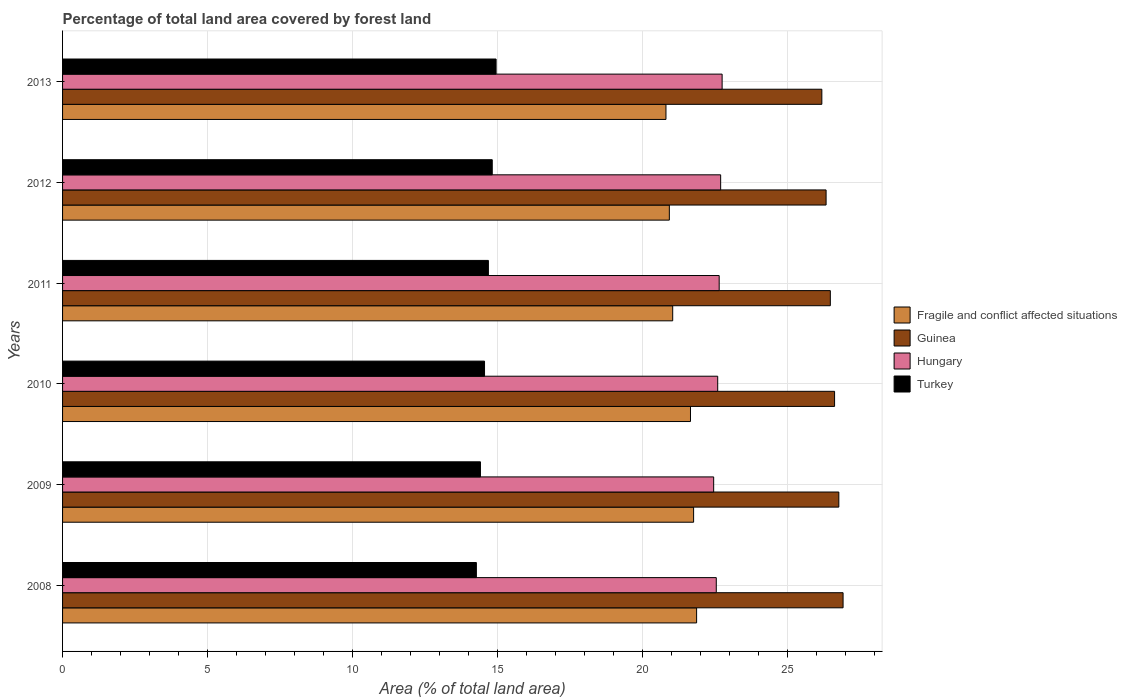How many groups of bars are there?
Your answer should be very brief. 6. What is the label of the 6th group of bars from the top?
Keep it short and to the point. 2008. What is the percentage of forest land in Fragile and conflict affected situations in 2010?
Ensure brevity in your answer.  21.66. Across all years, what is the maximum percentage of forest land in Guinea?
Ensure brevity in your answer.  26.92. Across all years, what is the minimum percentage of forest land in Guinea?
Give a very brief answer. 26.19. In which year was the percentage of forest land in Hungary minimum?
Your answer should be compact. 2009. What is the total percentage of forest land in Hungary in the graph?
Ensure brevity in your answer.  135.72. What is the difference between the percentage of forest land in Fragile and conflict affected situations in 2010 and that in 2012?
Provide a short and direct response. 0.73. What is the difference between the percentage of forest land in Guinea in 2009 and the percentage of forest land in Fragile and conflict affected situations in 2013?
Ensure brevity in your answer.  5.96. What is the average percentage of forest land in Guinea per year?
Your answer should be compact. 26.56. In the year 2012, what is the difference between the percentage of forest land in Fragile and conflict affected situations and percentage of forest land in Hungary?
Offer a very short reply. -1.77. In how many years, is the percentage of forest land in Hungary greater than 20 %?
Provide a short and direct response. 6. What is the ratio of the percentage of forest land in Hungary in 2008 to that in 2012?
Your answer should be compact. 0.99. What is the difference between the highest and the second highest percentage of forest land in Guinea?
Give a very brief answer. 0.15. What is the difference between the highest and the lowest percentage of forest land in Fragile and conflict affected situations?
Your answer should be compact. 1.06. What does the 2nd bar from the top in 2013 represents?
Give a very brief answer. Hungary. Are all the bars in the graph horizontal?
Offer a terse response. Yes. What is the difference between two consecutive major ticks on the X-axis?
Provide a succinct answer. 5. Are the values on the major ticks of X-axis written in scientific E-notation?
Offer a very short reply. No. Does the graph contain grids?
Provide a succinct answer. Yes. How are the legend labels stacked?
Your answer should be very brief. Vertical. What is the title of the graph?
Ensure brevity in your answer.  Percentage of total land area covered by forest land. What is the label or title of the X-axis?
Your answer should be very brief. Area (% of total land area). What is the Area (% of total land area) in Fragile and conflict affected situations in 2008?
Give a very brief answer. 21.87. What is the Area (% of total land area) in Guinea in 2008?
Your answer should be compact. 26.92. What is the Area (% of total land area) of Hungary in 2008?
Offer a terse response. 22.55. What is the Area (% of total land area) in Turkey in 2008?
Offer a terse response. 14.28. What is the Area (% of total land area) in Fragile and conflict affected situations in 2009?
Make the answer very short. 21.77. What is the Area (% of total land area) in Guinea in 2009?
Provide a short and direct response. 26.78. What is the Area (% of total land area) of Hungary in 2009?
Make the answer very short. 22.46. What is the Area (% of total land area) of Turkey in 2009?
Offer a terse response. 14.42. What is the Area (% of total land area) in Fragile and conflict affected situations in 2010?
Your answer should be very brief. 21.66. What is the Area (% of total land area) in Guinea in 2010?
Your response must be concise. 26.63. What is the Area (% of total land area) in Hungary in 2010?
Provide a succinct answer. 22.6. What is the Area (% of total land area) of Turkey in 2010?
Keep it short and to the point. 14.56. What is the Area (% of total land area) of Fragile and conflict affected situations in 2011?
Give a very brief answer. 21.05. What is the Area (% of total land area) of Guinea in 2011?
Make the answer very short. 26.49. What is the Area (% of total land area) in Hungary in 2011?
Offer a very short reply. 22.65. What is the Area (% of total land area) of Turkey in 2011?
Your answer should be very brief. 14.69. What is the Area (% of total land area) of Fragile and conflict affected situations in 2012?
Your answer should be very brief. 20.93. What is the Area (% of total land area) in Guinea in 2012?
Your answer should be very brief. 26.34. What is the Area (% of total land area) of Hungary in 2012?
Offer a terse response. 22.7. What is the Area (% of total land area) of Turkey in 2012?
Keep it short and to the point. 14.82. What is the Area (% of total land area) of Fragile and conflict affected situations in 2013?
Your answer should be compact. 20.82. What is the Area (% of total land area) in Guinea in 2013?
Your answer should be very brief. 26.19. What is the Area (% of total land area) of Hungary in 2013?
Ensure brevity in your answer.  22.75. What is the Area (% of total land area) of Turkey in 2013?
Provide a succinct answer. 14.96. Across all years, what is the maximum Area (% of total land area) of Fragile and conflict affected situations?
Ensure brevity in your answer.  21.87. Across all years, what is the maximum Area (% of total land area) of Guinea?
Make the answer very short. 26.92. Across all years, what is the maximum Area (% of total land area) of Hungary?
Provide a succinct answer. 22.75. Across all years, what is the maximum Area (% of total land area) of Turkey?
Your answer should be very brief. 14.96. Across all years, what is the minimum Area (% of total land area) of Fragile and conflict affected situations?
Ensure brevity in your answer.  20.82. Across all years, what is the minimum Area (% of total land area) in Guinea?
Your answer should be very brief. 26.19. Across all years, what is the minimum Area (% of total land area) of Hungary?
Your answer should be very brief. 22.46. Across all years, what is the minimum Area (% of total land area) of Turkey?
Your answer should be compact. 14.28. What is the total Area (% of total land area) of Fragile and conflict affected situations in the graph?
Offer a very short reply. 128.1. What is the total Area (% of total land area) of Guinea in the graph?
Your answer should be very brief. 159.35. What is the total Area (% of total land area) of Hungary in the graph?
Make the answer very short. 135.72. What is the total Area (% of total land area) in Turkey in the graph?
Keep it short and to the point. 87.71. What is the difference between the Area (% of total land area) of Fragile and conflict affected situations in 2008 and that in 2009?
Offer a terse response. 0.1. What is the difference between the Area (% of total land area) of Guinea in 2008 and that in 2009?
Provide a short and direct response. 0.15. What is the difference between the Area (% of total land area) in Hungary in 2008 and that in 2009?
Give a very brief answer. 0.09. What is the difference between the Area (% of total land area) of Turkey in 2008 and that in 2009?
Keep it short and to the point. -0.14. What is the difference between the Area (% of total land area) of Fragile and conflict affected situations in 2008 and that in 2010?
Your answer should be compact. 0.21. What is the difference between the Area (% of total land area) of Guinea in 2008 and that in 2010?
Offer a very short reply. 0.29. What is the difference between the Area (% of total land area) of Hungary in 2008 and that in 2010?
Keep it short and to the point. -0.05. What is the difference between the Area (% of total land area) in Turkey in 2008 and that in 2010?
Offer a terse response. -0.28. What is the difference between the Area (% of total land area) of Fragile and conflict affected situations in 2008 and that in 2011?
Offer a very short reply. 0.83. What is the difference between the Area (% of total land area) in Guinea in 2008 and that in 2011?
Provide a short and direct response. 0.44. What is the difference between the Area (% of total land area) of Hungary in 2008 and that in 2011?
Offer a very short reply. -0.1. What is the difference between the Area (% of total land area) of Turkey in 2008 and that in 2011?
Your answer should be very brief. -0.41. What is the difference between the Area (% of total land area) of Fragile and conflict affected situations in 2008 and that in 2012?
Provide a succinct answer. 0.94. What is the difference between the Area (% of total land area) of Guinea in 2008 and that in 2012?
Provide a short and direct response. 0.59. What is the difference between the Area (% of total land area) in Hungary in 2008 and that in 2012?
Provide a short and direct response. -0.15. What is the difference between the Area (% of total land area) of Turkey in 2008 and that in 2012?
Offer a very short reply. -0.55. What is the difference between the Area (% of total land area) in Fragile and conflict affected situations in 2008 and that in 2013?
Give a very brief answer. 1.06. What is the difference between the Area (% of total land area) in Guinea in 2008 and that in 2013?
Offer a terse response. 0.73. What is the difference between the Area (% of total land area) in Hungary in 2008 and that in 2013?
Offer a very short reply. -0.2. What is the difference between the Area (% of total land area) of Turkey in 2008 and that in 2013?
Keep it short and to the point. -0.68. What is the difference between the Area (% of total land area) in Fragile and conflict affected situations in 2009 and that in 2010?
Your answer should be very brief. 0.11. What is the difference between the Area (% of total land area) of Guinea in 2009 and that in 2010?
Offer a terse response. 0.15. What is the difference between the Area (% of total land area) of Hungary in 2009 and that in 2010?
Your answer should be very brief. -0.14. What is the difference between the Area (% of total land area) of Turkey in 2009 and that in 2010?
Your answer should be very brief. -0.14. What is the difference between the Area (% of total land area) in Fragile and conflict affected situations in 2009 and that in 2011?
Make the answer very short. 0.72. What is the difference between the Area (% of total land area) in Guinea in 2009 and that in 2011?
Provide a short and direct response. 0.29. What is the difference between the Area (% of total land area) in Hungary in 2009 and that in 2011?
Provide a short and direct response. -0.19. What is the difference between the Area (% of total land area) in Turkey in 2009 and that in 2011?
Provide a short and direct response. -0.27. What is the difference between the Area (% of total land area) of Fragile and conflict affected situations in 2009 and that in 2012?
Offer a terse response. 0.84. What is the difference between the Area (% of total land area) in Guinea in 2009 and that in 2012?
Provide a succinct answer. 0.44. What is the difference between the Area (% of total land area) in Hungary in 2009 and that in 2012?
Ensure brevity in your answer.  -0.24. What is the difference between the Area (% of total land area) in Turkey in 2009 and that in 2012?
Make the answer very short. -0.41. What is the difference between the Area (% of total land area) of Fragile and conflict affected situations in 2009 and that in 2013?
Keep it short and to the point. 0.95. What is the difference between the Area (% of total land area) in Guinea in 2009 and that in 2013?
Your response must be concise. 0.59. What is the difference between the Area (% of total land area) in Hungary in 2009 and that in 2013?
Provide a succinct answer. -0.29. What is the difference between the Area (% of total land area) in Turkey in 2009 and that in 2013?
Offer a very short reply. -0.54. What is the difference between the Area (% of total land area) of Fragile and conflict affected situations in 2010 and that in 2011?
Ensure brevity in your answer.  0.61. What is the difference between the Area (% of total land area) in Guinea in 2010 and that in 2011?
Your answer should be very brief. 0.15. What is the difference between the Area (% of total land area) in Hungary in 2010 and that in 2011?
Provide a short and direct response. -0.05. What is the difference between the Area (% of total land area) of Turkey in 2010 and that in 2011?
Make the answer very short. -0.13. What is the difference between the Area (% of total land area) of Fragile and conflict affected situations in 2010 and that in 2012?
Give a very brief answer. 0.73. What is the difference between the Area (% of total land area) in Guinea in 2010 and that in 2012?
Keep it short and to the point. 0.29. What is the difference between the Area (% of total land area) in Hungary in 2010 and that in 2012?
Provide a short and direct response. -0.1. What is the difference between the Area (% of total land area) in Turkey in 2010 and that in 2012?
Give a very brief answer. -0.27. What is the difference between the Area (% of total land area) of Fragile and conflict affected situations in 2010 and that in 2013?
Make the answer very short. 0.85. What is the difference between the Area (% of total land area) of Guinea in 2010 and that in 2013?
Provide a short and direct response. 0.44. What is the difference between the Area (% of total land area) of Hungary in 2010 and that in 2013?
Keep it short and to the point. -0.15. What is the difference between the Area (% of total land area) in Turkey in 2010 and that in 2013?
Your response must be concise. -0.4. What is the difference between the Area (% of total land area) of Fragile and conflict affected situations in 2011 and that in 2012?
Keep it short and to the point. 0.12. What is the difference between the Area (% of total land area) in Guinea in 2011 and that in 2012?
Your response must be concise. 0.15. What is the difference between the Area (% of total land area) in Hungary in 2011 and that in 2012?
Ensure brevity in your answer.  -0.05. What is the difference between the Area (% of total land area) of Turkey in 2011 and that in 2012?
Your answer should be compact. -0.13. What is the difference between the Area (% of total land area) of Fragile and conflict affected situations in 2011 and that in 2013?
Make the answer very short. 0.23. What is the difference between the Area (% of total land area) of Guinea in 2011 and that in 2013?
Your answer should be compact. 0.29. What is the difference between the Area (% of total land area) of Hungary in 2011 and that in 2013?
Your answer should be very brief. -0.1. What is the difference between the Area (% of total land area) in Turkey in 2011 and that in 2013?
Provide a succinct answer. -0.27. What is the difference between the Area (% of total land area) in Fragile and conflict affected situations in 2012 and that in 2013?
Provide a short and direct response. 0.12. What is the difference between the Area (% of total land area) in Guinea in 2012 and that in 2013?
Offer a very short reply. 0.15. What is the difference between the Area (% of total land area) in Hungary in 2012 and that in 2013?
Offer a very short reply. -0.05. What is the difference between the Area (% of total land area) in Turkey in 2012 and that in 2013?
Ensure brevity in your answer.  -0.13. What is the difference between the Area (% of total land area) in Fragile and conflict affected situations in 2008 and the Area (% of total land area) in Guinea in 2009?
Offer a very short reply. -4.91. What is the difference between the Area (% of total land area) of Fragile and conflict affected situations in 2008 and the Area (% of total land area) of Hungary in 2009?
Offer a very short reply. -0.59. What is the difference between the Area (% of total land area) of Fragile and conflict affected situations in 2008 and the Area (% of total land area) of Turkey in 2009?
Your response must be concise. 7.46. What is the difference between the Area (% of total land area) in Guinea in 2008 and the Area (% of total land area) in Hungary in 2009?
Make the answer very short. 4.46. What is the difference between the Area (% of total land area) of Guinea in 2008 and the Area (% of total land area) of Turkey in 2009?
Your response must be concise. 12.51. What is the difference between the Area (% of total land area) of Hungary in 2008 and the Area (% of total land area) of Turkey in 2009?
Keep it short and to the point. 8.14. What is the difference between the Area (% of total land area) of Fragile and conflict affected situations in 2008 and the Area (% of total land area) of Guinea in 2010?
Your answer should be very brief. -4.76. What is the difference between the Area (% of total land area) of Fragile and conflict affected situations in 2008 and the Area (% of total land area) of Hungary in 2010?
Your answer should be very brief. -0.73. What is the difference between the Area (% of total land area) in Fragile and conflict affected situations in 2008 and the Area (% of total land area) in Turkey in 2010?
Your response must be concise. 7.32. What is the difference between the Area (% of total land area) in Guinea in 2008 and the Area (% of total land area) in Hungary in 2010?
Provide a short and direct response. 4.32. What is the difference between the Area (% of total land area) of Guinea in 2008 and the Area (% of total land area) of Turkey in 2010?
Give a very brief answer. 12.37. What is the difference between the Area (% of total land area) in Hungary in 2008 and the Area (% of total land area) in Turkey in 2010?
Offer a terse response. 7.99. What is the difference between the Area (% of total land area) of Fragile and conflict affected situations in 2008 and the Area (% of total land area) of Guinea in 2011?
Ensure brevity in your answer.  -4.61. What is the difference between the Area (% of total land area) of Fragile and conflict affected situations in 2008 and the Area (% of total land area) of Hungary in 2011?
Offer a very short reply. -0.78. What is the difference between the Area (% of total land area) of Fragile and conflict affected situations in 2008 and the Area (% of total land area) of Turkey in 2011?
Keep it short and to the point. 7.18. What is the difference between the Area (% of total land area) in Guinea in 2008 and the Area (% of total land area) in Hungary in 2011?
Keep it short and to the point. 4.27. What is the difference between the Area (% of total land area) of Guinea in 2008 and the Area (% of total land area) of Turkey in 2011?
Provide a short and direct response. 12.24. What is the difference between the Area (% of total land area) in Hungary in 2008 and the Area (% of total land area) in Turkey in 2011?
Offer a terse response. 7.86. What is the difference between the Area (% of total land area) of Fragile and conflict affected situations in 2008 and the Area (% of total land area) of Guinea in 2012?
Provide a short and direct response. -4.47. What is the difference between the Area (% of total land area) of Fragile and conflict affected situations in 2008 and the Area (% of total land area) of Hungary in 2012?
Your response must be concise. -0.83. What is the difference between the Area (% of total land area) of Fragile and conflict affected situations in 2008 and the Area (% of total land area) of Turkey in 2012?
Provide a succinct answer. 7.05. What is the difference between the Area (% of total land area) of Guinea in 2008 and the Area (% of total land area) of Hungary in 2012?
Provide a short and direct response. 4.22. What is the difference between the Area (% of total land area) in Guinea in 2008 and the Area (% of total land area) in Turkey in 2012?
Your answer should be compact. 12.1. What is the difference between the Area (% of total land area) of Hungary in 2008 and the Area (% of total land area) of Turkey in 2012?
Offer a very short reply. 7.73. What is the difference between the Area (% of total land area) in Fragile and conflict affected situations in 2008 and the Area (% of total land area) in Guinea in 2013?
Ensure brevity in your answer.  -4.32. What is the difference between the Area (% of total land area) of Fragile and conflict affected situations in 2008 and the Area (% of total land area) of Hungary in 2013?
Keep it short and to the point. -0.88. What is the difference between the Area (% of total land area) in Fragile and conflict affected situations in 2008 and the Area (% of total land area) in Turkey in 2013?
Give a very brief answer. 6.92. What is the difference between the Area (% of total land area) in Guinea in 2008 and the Area (% of total land area) in Hungary in 2013?
Offer a terse response. 4.17. What is the difference between the Area (% of total land area) in Guinea in 2008 and the Area (% of total land area) in Turkey in 2013?
Your answer should be compact. 11.97. What is the difference between the Area (% of total land area) of Hungary in 2008 and the Area (% of total land area) of Turkey in 2013?
Provide a short and direct response. 7.6. What is the difference between the Area (% of total land area) of Fragile and conflict affected situations in 2009 and the Area (% of total land area) of Guinea in 2010?
Your answer should be very brief. -4.86. What is the difference between the Area (% of total land area) in Fragile and conflict affected situations in 2009 and the Area (% of total land area) in Hungary in 2010?
Provide a short and direct response. -0.83. What is the difference between the Area (% of total land area) in Fragile and conflict affected situations in 2009 and the Area (% of total land area) in Turkey in 2010?
Keep it short and to the point. 7.21. What is the difference between the Area (% of total land area) in Guinea in 2009 and the Area (% of total land area) in Hungary in 2010?
Give a very brief answer. 4.18. What is the difference between the Area (% of total land area) of Guinea in 2009 and the Area (% of total land area) of Turkey in 2010?
Give a very brief answer. 12.22. What is the difference between the Area (% of total land area) in Hungary in 2009 and the Area (% of total land area) in Turkey in 2010?
Keep it short and to the point. 7.9. What is the difference between the Area (% of total land area) of Fragile and conflict affected situations in 2009 and the Area (% of total land area) of Guinea in 2011?
Make the answer very short. -4.72. What is the difference between the Area (% of total land area) in Fragile and conflict affected situations in 2009 and the Area (% of total land area) in Hungary in 2011?
Your answer should be very brief. -0.88. What is the difference between the Area (% of total land area) of Fragile and conflict affected situations in 2009 and the Area (% of total land area) of Turkey in 2011?
Keep it short and to the point. 7.08. What is the difference between the Area (% of total land area) of Guinea in 2009 and the Area (% of total land area) of Hungary in 2011?
Your response must be concise. 4.13. What is the difference between the Area (% of total land area) in Guinea in 2009 and the Area (% of total land area) in Turkey in 2011?
Your answer should be very brief. 12.09. What is the difference between the Area (% of total land area) in Hungary in 2009 and the Area (% of total land area) in Turkey in 2011?
Offer a very short reply. 7.77. What is the difference between the Area (% of total land area) of Fragile and conflict affected situations in 2009 and the Area (% of total land area) of Guinea in 2012?
Provide a short and direct response. -4.57. What is the difference between the Area (% of total land area) of Fragile and conflict affected situations in 2009 and the Area (% of total land area) of Hungary in 2012?
Make the answer very short. -0.93. What is the difference between the Area (% of total land area) of Fragile and conflict affected situations in 2009 and the Area (% of total land area) of Turkey in 2012?
Your answer should be very brief. 6.95. What is the difference between the Area (% of total land area) in Guinea in 2009 and the Area (% of total land area) in Hungary in 2012?
Your answer should be very brief. 4.08. What is the difference between the Area (% of total land area) of Guinea in 2009 and the Area (% of total land area) of Turkey in 2012?
Ensure brevity in your answer.  11.96. What is the difference between the Area (% of total land area) of Hungary in 2009 and the Area (% of total land area) of Turkey in 2012?
Offer a terse response. 7.64. What is the difference between the Area (% of total land area) of Fragile and conflict affected situations in 2009 and the Area (% of total land area) of Guinea in 2013?
Offer a very short reply. -4.42. What is the difference between the Area (% of total land area) in Fragile and conflict affected situations in 2009 and the Area (% of total land area) in Hungary in 2013?
Provide a short and direct response. -0.98. What is the difference between the Area (% of total land area) in Fragile and conflict affected situations in 2009 and the Area (% of total land area) in Turkey in 2013?
Offer a very short reply. 6.81. What is the difference between the Area (% of total land area) in Guinea in 2009 and the Area (% of total land area) in Hungary in 2013?
Offer a very short reply. 4.03. What is the difference between the Area (% of total land area) in Guinea in 2009 and the Area (% of total land area) in Turkey in 2013?
Keep it short and to the point. 11.82. What is the difference between the Area (% of total land area) of Hungary in 2009 and the Area (% of total land area) of Turkey in 2013?
Offer a terse response. 7.51. What is the difference between the Area (% of total land area) in Fragile and conflict affected situations in 2010 and the Area (% of total land area) in Guinea in 2011?
Give a very brief answer. -4.82. What is the difference between the Area (% of total land area) of Fragile and conflict affected situations in 2010 and the Area (% of total land area) of Hungary in 2011?
Offer a terse response. -0.99. What is the difference between the Area (% of total land area) of Fragile and conflict affected situations in 2010 and the Area (% of total land area) of Turkey in 2011?
Offer a very short reply. 6.97. What is the difference between the Area (% of total land area) of Guinea in 2010 and the Area (% of total land area) of Hungary in 2011?
Make the answer very short. 3.98. What is the difference between the Area (% of total land area) in Guinea in 2010 and the Area (% of total land area) in Turkey in 2011?
Provide a short and direct response. 11.94. What is the difference between the Area (% of total land area) of Hungary in 2010 and the Area (% of total land area) of Turkey in 2011?
Keep it short and to the point. 7.91. What is the difference between the Area (% of total land area) of Fragile and conflict affected situations in 2010 and the Area (% of total land area) of Guinea in 2012?
Give a very brief answer. -4.68. What is the difference between the Area (% of total land area) in Fragile and conflict affected situations in 2010 and the Area (% of total land area) in Hungary in 2012?
Your answer should be very brief. -1.04. What is the difference between the Area (% of total land area) in Fragile and conflict affected situations in 2010 and the Area (% of total land area) in Turkey in 2012?
Offer a very short reply. 6.84. What is the difference between the Area (% of total land area) in Guinea in 2010 and the Area (% of total land area) in Hungary in 2012?
Give a very brief answer. 3.93. What is the difference between the Area (% of total land area) of Guinea in 2010 and the Area (% of total land area) of Turkey in 2012?
Ensure brevity in your answer.  11.81. What is the difference between the Area (% of total land area) in Hungary in 2010 and the Area (% of total land area) in Turkey in 2012?
Provide a short and direct response. 7.78. What is the difference between the Area (% of total land area) in Fragile and conflict affected situations in 2010 and the Area (% of total land area) in Guinea in 2013?
Provide a short and direct response. -4.53. What is the difference between the Area (% of total land area) of Fragile and conflict affected situations in 2010 and the Area (% of total land area) of Hungary in 2013?
Ensure brevity in your answer.  -1.09. What is the difference between the Area (% of total land area) of Fragile and conflict affected situations in 2010 and the Area (% of total land area) of Turkey in 2013?
Your answer should be very brief. 6.71. What is the difference between the Area (% of total land area) of Guinea in 2010 and the Area (% of total land area) of Hungary in 2013?
Your response must be concise. 3.88. What is the difference between the Area (% of total land area) in Guinea in 2010 and the Area (% of total land area) in Turkey in 2013?
Your response must be concise. 11.68. What is the difference between the Area (% of total land area) of Hungary in 2010 and the Area (% of total land area) of Turkey in 2013?
Your answer should be compact. 7.64. What is the difference between the Area (% of total land area) in Fragile and conflict affected situations in 2011 and the Area (% of total land area) in Guinea in 2012?
Ensure brevity in your answer.  -5.29. What is the difference between the Area (% of total land area) of Fragile and conflict affected situations in 2011 and the Area (% of total land area) of Hungary in 2012?
Your answer should be very brief. -1.65. What is the difference between the Area (% of total land area) in Fragile and conflict affected situations in 2011 and the Area (% of total land area) in Turkey in 2012?
Your response must be concise. 6.22. What is the difference between the Area (% of total land area) in Guinea in 2011 and the Area (% of total land area) in Hungary in 2012?
Your answer should be very brief. 3.78. What is the difference between the Area (% of total land area) in Guinea in 2011 and the Area (% of total land area) in Turkey in 2012?
Offer a terse response. 11.66. What is the difference between the Area (% of total land area) of Hungary in 2011 and the Area (% of total land area) of Turkey in 2012?
Your answer should be very brief. 7.83. What is the difference between the Area (% of total land area) of Fragile and conflict affected situations in 2011 and the Area (% of total land area) of Guinea in 2013?
Make the answer very short. -5.14. What is the difference between the Area (% of total land area) in Fragile and conflict affected situations in 2011 and the Area (% of total land area) in Hungary in 2013?
Offer a very short reply. -1.71. What is the difference between the Area (% of total land area) of Fragile and conflict affected situations in 2011 and the Area (% of total land area) of Turkey in 2013?
Offer a terse response. 6.09. What is the difference between the Area (% of total land area) of Guinea in 2011 and the Area (% of total land area) of Hungary in 2013?
Ensure brevity in your answer.  3.73. What is the difference between the Area (% of total land area) in Guinea in 2011 and the Area (% of total land area) in Turkey in 2013?
Offer a very short reply. 11.53. What is the difference between the Area (% of total land area) of Hungary in 2011 and the Area (% of total land area) of Turkey in 2013?
Ensure brevity in your answer.  7.7. What is the difference between the Area (% of total land area) in Fragile and conflict affected situations in 2012 and the Area (% of total land area) in Guinea in 2013?
Your answer should be very brief. -5.26. What is the difference between the Area (% of total land area) in Fragile and conflict affected situations in 2012 and the Area (% of total land area) in Hungary in 2013?
Your answer should be very brief. -1.82. What is the difference between the Area (% of total land area) in Fragile and conflict affected situations in 2012 and the Area (% of total land area) in Turkey in 2013?
Provide a short and direct response. 5.98. What is the difference between the Area (% of total land area) of Guinea in 2012 and the Area (% of total land area) of Hungary in 2013?
Ensure brevity in your answer.  3.59. What is the difference between the Area (% of total land area) of Guinea in 2012 and the Area (% of total land area) of Turkey in 2013?
Your answer should be very brief. 11.38. What is the difference between the Area (% of total land area) in Hungary in 2012 and the Area (% of total land area) in Turkey in 2013?
Your answer should be compact. 7.75. What is the average Area (% of total land area) in Fragile and conflict affected situations per year?
Make the answer very short. 21.35. What is the average Area (% of total land area) in Guinea per year?
Provide a short and direct response. 26.56. What is the average Area (% of total land area) of Hungary per year?
Keep it short and to the point. 22.62. What is the average Area (% of total land area) in Turkey per year?
Provide a short and direct response. 14.62. In the year 2008, what is the difference between the Area (% of total land area) in Fragile and conflict affected situations and Area (% of total land area) in Guinea?
Your answer should be compact. -5.05. In the year 2008, what is the difference between the Area (% of total land area) of Fragile and conflict affected situations and Area (% of total land area) of Hungary?
Ensure brevity in your answer.  -0.68. In the year 2008, what is the difference between the Area (% of total land area) in Fragile and conflict affected situations and Area (% of total land area) in Turkey?
Provide a short and direct response. 7.6. In the year 2008, what is the difference between the Area (% of total land area) of Guinea and Area (% of total land area) of Hungary?
Your answer should be compact. 4.37. In the year 2008, what is the difference between the Area (% of total land area) in Guinea and Area (% of total land area) in Turkey?
Make the answer very short. 12.65. In the year 2008, what is the difference between the Area (% of total land area) in Hungary and Area (% of total land area) in Turkey?
Your answer should be compact. 8.28. In the year 2009, what is the difference between the Area (% of total land area) in Fragile and conflict affected situations and Area (% of total land area) in Guinea?
Provide a short and direct response. -5.01. In the year 2009, what is the difference between the Area (% of total land area) in Fragile and conflict affected situations and Area (% of total land area) in Hungary?
Provide a short and direct response. -0.69. In the year 2009, what is the difference between the Area (% of total land area) in Fragile and conflict affected situations and Area (% of total land area) in Turkey?
Your answer should be very brief. 7.35. In the year 2009, what is the difference between the Area (% of total land area) of Guinea and Area (% of total land area) of Hungary?
Offer a terse response. 4.32. In the year 2009, what is the difference between the Area (% of total land area) in Guinea and Area (% of total land area) in Turkey?
Your answer should be compact. 12.36. In the year 2009, what is the difference between the Area (% of total land area) in Hungary and Area (% of total land area) in Turkey?
Offer a terse response. 8.05. In the year 2010, what is the difference between the Area (% of total land area) of Fragile and conflict affected situations and Area (% of total land area) of Guinea?
Keep it short and to the point. -4.97. In the year 2010, what is the difference between the Area (% of total land area) of Fragile and conflict affected situations and Area (% of total land area) of Hungary?
Give a very brief answer. -0.94. In the year 2010, what is the difference between the Area (% of total land area) in Fragile and conflict affected situations and Area (% of total land area) in Turkey?
Your answer should be very brief. 7.1. In the year 2010, what is the difference between the Area (% of total land area) in Guinea and Area (% of total land area) in Hungary?
Offer a terse response. 4.03. In the year 2010, what is the difference between the Area (% of total land area) in Guinea and Area (% of total land area) in Turkey?
Give a very brief answer. 12.08. In the year 2010, what is the difference between the Area (% of total land area) of Hungary and Area (% of total land area) of Turkey?
Your answer should be compact. 8.04. In the year 2011, what is the difference between the Area (% of total land area) of Fragile and conflict affected situations and Area (% of total land area) of Guinea?
Keep it short and to the point. -5.44. In the year 2011, what is the difference between the Area (% of total land area) in Fragile and conflict affected situations and Area (% of total land area) in Hungary?
Your answer should be very brief. -1.6. In the year 2011, what is the difference between the Area (% of total land area) of Fragile and conflict affected situations and Area (% of total land area) of Turkey?
Provide a short and direct response. 6.36. In the year 2011, what is the difference between the Area (% of total land area) in Guinea and Area (% of total land area) in Hungary?
Your response must be concise. 3.83. In the year 2011, what is the difference between the Area (% of total land area) in Guinea and Area (% of total land area) in Turkey?
Your answer should be compact. 11.8. In the year 2011, what is the difference between the Area (% of total land area) of Hungary and Area (% of total land area) of Turkey?
Make the answer very short. 7.96. In the year 2012, what is the difference between the Area (% of total land area) of Fragile and conflict affected situations and Area (% of total land area) of Guinea?
Give a very brief answer. -5.41. In the year 2012, what is the difference between the Area (% of total land area) of Fragile and conflict affected situations and Area (% of total land area) of Hungary?
Provide a short and direct response. -1.77. In the year 2012, what is the difference between the Area (% of total land area) in Fragile and conflict affected situations and Area (% of total land area) in Turkey?
Ensure brevity in your answer.  6.11. In the year 2012, what is the difference between the Area (% of total land area) in Guinea and Area (% of total land area) in Hungary?
Make the answer very short. 3.64. In the year 2012, what is the difference between the Area (% of total land area) of Guinea and Area (% of total land area) of Turkey?
Make the answer very short. 11.52. In the year 2012, what is the difference between the Area (% of total land area) in Hungary and Area (% of total land area) in Turkey?
Make the answer very short. 7.88. In the year 2013, what is the difference between the Area (% of total land area) in Fragile and conflict affected situations and Area (% of total land area) in Guinea?
Your answer should be very brief. -5.38. In the year 2013, what is the difference between the Area (% of total land area) in Fragile and conflict affected situations and Area (% of total land area) in Hungary?
Ensure brevity in your answer.  -1.94. In the year 2013, what is the difference between the Area (% of total land area) in Fragile and conflict affected situations and Area (% of total land area) in Turkey?
Your answer should be compact. 5.86. In the year 2013, what is the difference between the Area (% of total land area) in Guinea and Area (% of total land area) in Hungary?
Offer a terse response. 3.44. In the year 2013, what is the difference between the Area (% of total land area) of Guinea and Area (% of total land area) of Turkey?
Keep it short and to the point. 11.24. In the year 2013, what is the difference between the Area (% of total land area) of Hungary and Area (% of total land area) of Turkey?
Provide a succinct answer. 7.8. What is the ratio of the Area (% of total land area) in Fragile and conflict affected situations in 2008 to that in 2009?
Keep it short and to the point. 1. What is the ratio of the Area (% of total land area) in Guinea in 2008 to that in 2009?
Provide a succinct answer. 1.01. What is the ratio of the Area (% of total land area) of Turkey in 2008 to that in 2009?
Make the answer very short. 0.99. What is the ratio of the Area (% of total land area) of Fragile and conflict affected situations in 2008 to that in 2010?
Provide a short and direct response. 1.01. What is the ratio of the Area (% of total land area) in Turkey in 2008 to that in 2010?
Make the answer very short. 0.98. What is the ratio of the Area (% of total land area) in Fragile and conflict affected situations in 2008 to that in 2011?
Keep it short and to the point. 1.04. What is the ratio of the Area (% of total land area) of Guinea in 2008 to that in 2011?
Your answer should be very brief. 1.02. What is the ratio of the Area (% of total land area) of Turkey in 2008 to that in 2011?
Offer a very short reply. 0.97. What is the ratio of the Area (% of total land area) of Fragile and conflict affected situations in 2008 to that in 2012?
Offer a very short reply. 1.04. What is the ratio of the Area (% of total land area) of Guinea in 2008 to that in 2012?
Offer a terse response. 1.02. What is the ratio of the Area (% of total land area) of Hungary in 2008 to that in 2012?
Provide a short and direct response. 0.99. What is the ratio of the Area (% of total land area) of Turkey in 2008 to that in 2012?
Your answer should be very brief. 0.96. What is the ratio of the Area (% of total land area) of Fragile and conflict affected situations in 2008 to that in 2013?
Offer a terse response. 1.05. What is the ratio of the Area (% of total land area) in Guinea in 2008 to that in 2013?
Give a very brief answer. 1.03. What is the ratio of the Area (% of total land area) of Turkey in 2008 to that in 2013?
Give a very brief answer. 0.95. What is the ratio of the Area (% of total land area) in Fragile and conflict affected situations in 2009 to that in 2010?
Provide a succinct answer. 1. What is the ratio of the Area (% of total land area) in Hungary in 2009 to that in 2010?
Your answer should be very brief. 0.99. What is the ratio of the Area (% of total land area) in Turkey in 2009 to that in 2010?
Make the answer very short. 0.99. What is the ratio of the Area (% of total land area) of Fragile and conflict affected situations in 2009 to that in 2011?
Give a very brief answer. 1.03. What is the ratio of the Area (% of total land area) in Guinea in 2009 to that in 2011?
Give a very brief answer. 1.01. What is the ratio of the Area (% of total land area) in Turkey in 2009 to that in 2011?
Provide a short and direct response. 0.98. What is the ratio of the Area (% of total land area) of Fragile and conflict affected situations in 2009 to that in 2012?
Offer a terse response. 1.04. What is the ratio of the Area (% of total land area) of Guinea in 2009 to that in 2012?
Offer a very short reply. 1.02. What is the ratio of the Area (% of total land area) of Hungary in 2009 to that in 2012?
Ensure brevity in your answer.  0.99. What is the ratio of the Area (% of total land area) of Turkey in 2009 to that in 2012?
Provide a short and direct response. 0.97. What is the ratio of the Area (% of total land area) in Fragile and conflict affected situations in 2009 to that in 2013?
Your answer should be compact. 1.05. What is the ratio of the Area (% of total land area) in Guinea in 2009 to that in 2013?
Keep it short and to the point. 1.02. What is the ratio of the Area (% of total land area) of Hungary in 2009 to that in 2013?
Make the answer very short. 0.99. What is the ratio of the Area (% of total land area) of Turkey in 2009 to that in 2013?
Your response must be concise. 0.96. What is the ratio of the Area (% of total land area) in Fragile and conflict affected situations in 2010 to that in 2011?
Offer a very short reply. 1.03. What is the ratio of the Area (% of total land area) in Guinea in 2010 to that in 2011?
Make the answer very short. 1.01. What is the ratio of the Area (% of total land area) of Hungary in 2010 to that in 2011?
Your response must be concise. 1. What is the ratio of the Area (% of total land area) in Turkey in 2010 to that in 2011?
Ensure brevity in your answer.  0.99. What is the ratio of the Area (% of total land area) in Fragile and conflict affected situations in 2010 to that in 2012?
Ensure brevity in your answer.  1.03. What is the ratio of the Area (% of total land area) of Guinea in 2010 to that in 2012?
Make the answer very short. 1.01. What is the ratio of the Area (% of total land area) of Hungary in 2010 to that in 2012?
Offer a terse response. 1. What is the ratio of the Area (% of total land area) in Turkey in 2010 to that in 2012?
Ensure brevity in your answer.  0.98. What is the ratio of the Area (% of total land area) of Fragile and conflict affected situations in 2010 to that in 2013?
Provide a succinct answer. 1.04. What is the ratio of the Area (% of total land area) in Guinea in 2010 to that in 2013?
Your answer should be very brief. 1.02. What is the ratio of the Area (% of total land area) in Hungary in 2010 to that in 2013?
Ensure brevity in your answer.  0.99. What is the ratio of the Area (% of total land area) of Turkey in 2010 to that in 2013?
Ensure brevity in your answer.  0.97. What is the ratio of the Area (% of total land area) of Fragile and conflict affected situations in 2011 to that in 2012?
Provide a succinct answer. 1.01. What is the ratio of the Area (% of total land area) of Guinea in 2011 to that in 2012?
Ensure brevity in your answer.  1.01. What is the ratio of the Area (% of total land area) of Fragile and conflict affected situations in 2011 to that in 2013?
Provide a short and direct response. 1.01. What is the ratio of the Area (% of total land area) of Guinea in 2011 to that in 2013?
Offer a very short reply. 1.01. What is the ratio of the Area (% of total land area) of Hungary in 2011 to that in 2013?
Provide a short and direct response. 1. What is the ratio of the Area (% of total land area) of Turkey in 2011 to that in 2013?
Your response must be concise. 0.98. What is the ratio of the Area (% of total land area) in Fragile and conflict affected situations in 2012 to that in 2013?
Ensure brevity in your answer.  1.01. What is the ratio of the Area (% of total land area) in Guinea in 2012 to that in 2013?
Your answer should be compact. 1.01. What is the difference between the highest and the second highest Area (% of total land area) in Fragile and conflict affected situations?
Provide a succinct answer. 0.1. What is the difference between the highest and the second highest Area (% of total land area) in Guinea?
Provide a short and direct response. 0.15. What is the difference between the highest and the second highest Area (% of total land area) of Hungary?
Offer a terse response. 0.05. What is the difference between the highest and the second highest Area (% of total land area) in Turkey?
Ensure brevity in your answer.  0.13. What is the difference between the highest and the lowest Area (% of total land area) in Fragile and conflict affected situations?
Give a very brief answer. 1.06. What is the difference between the highest and the lowest Area (% of total land area) in Guinea?
Provide a short and direct response. 0.73. What is the difference between the highest and the lowest Area (% of total land area) of Hungary?
Offer a terse response. 0.29. What is the difference between the highest and the lowest Area (% of total land area) in Turkey?
Provide a short and direct response. 0.68. 